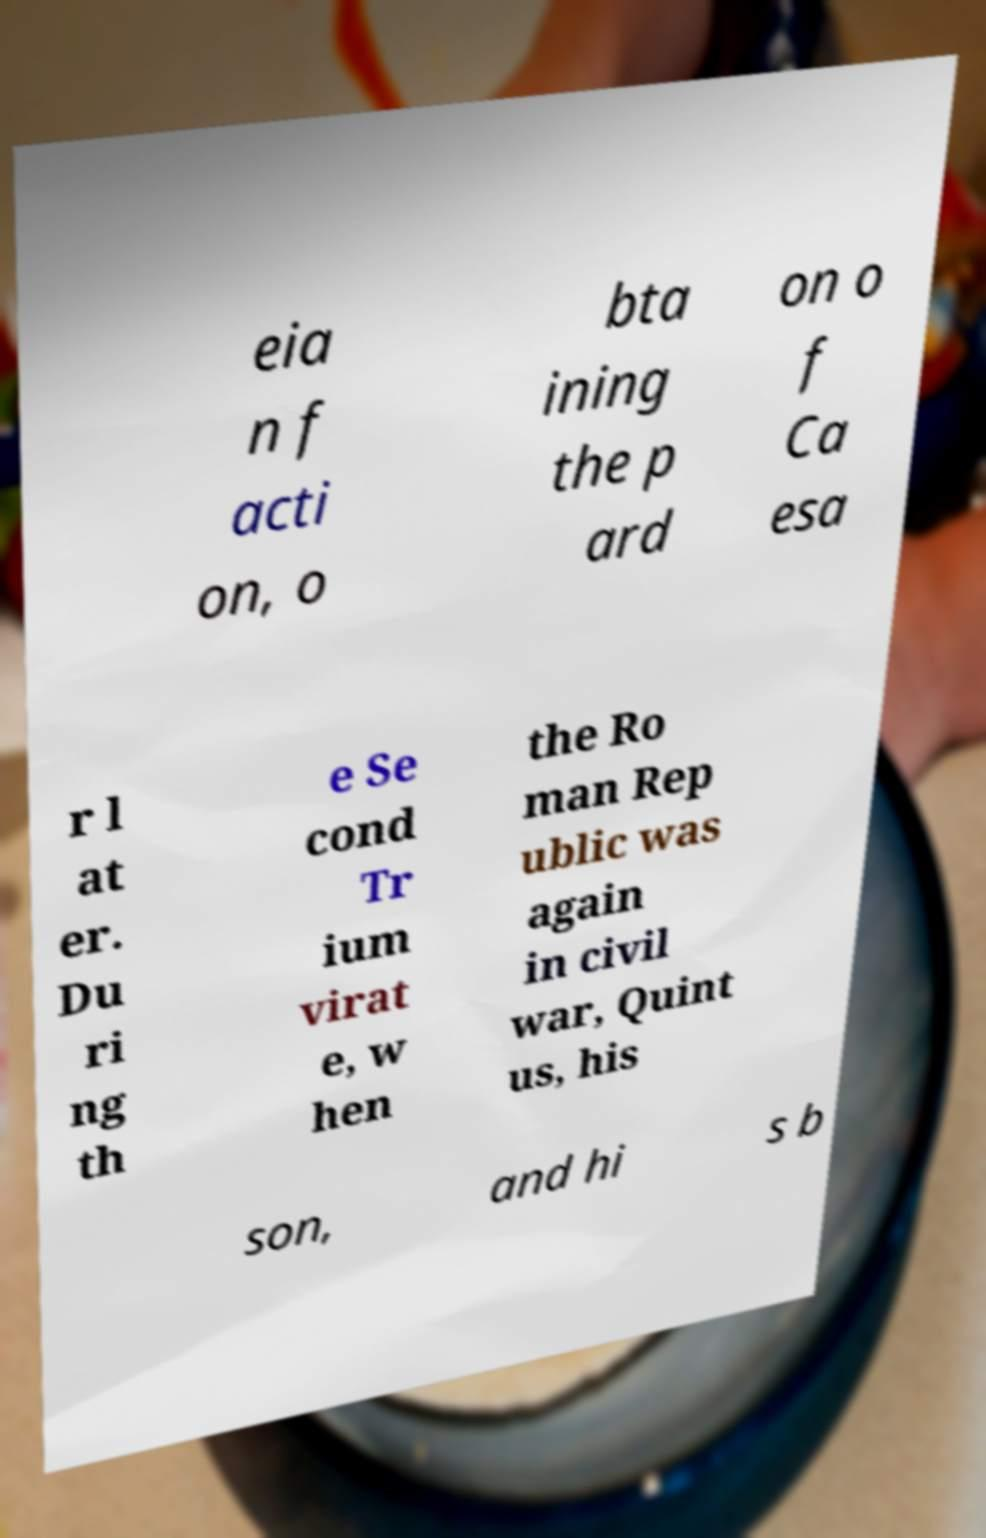Could you assist in decoding the text presented in this image and type it out clearly? eia n f acti on, o bta ining the p ard on o f Ca esa r l at er. Du ri ng th e Se cond Tr ium virat e, w hen the Ro man Rep ublic was again in civil war, Quint us, his son, and hi s b 